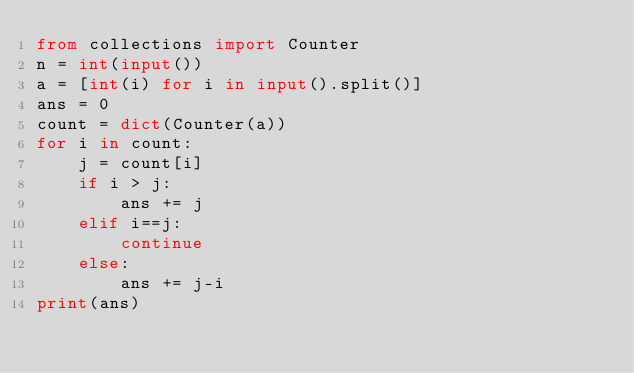Convert code to text. <code><loc_0><loc_0><loc_500><loc_500><_Python_>from collections import Counter
n = int(input())
a = [int(i) for i in input().split()]
ans = 0
count = dict(Counter(a))
for i in count:
    j = count[i]
    if i > j:
        ans += j
    elif i==j:
        continue
    else:
        ans += j-i
print(ans)</code> 